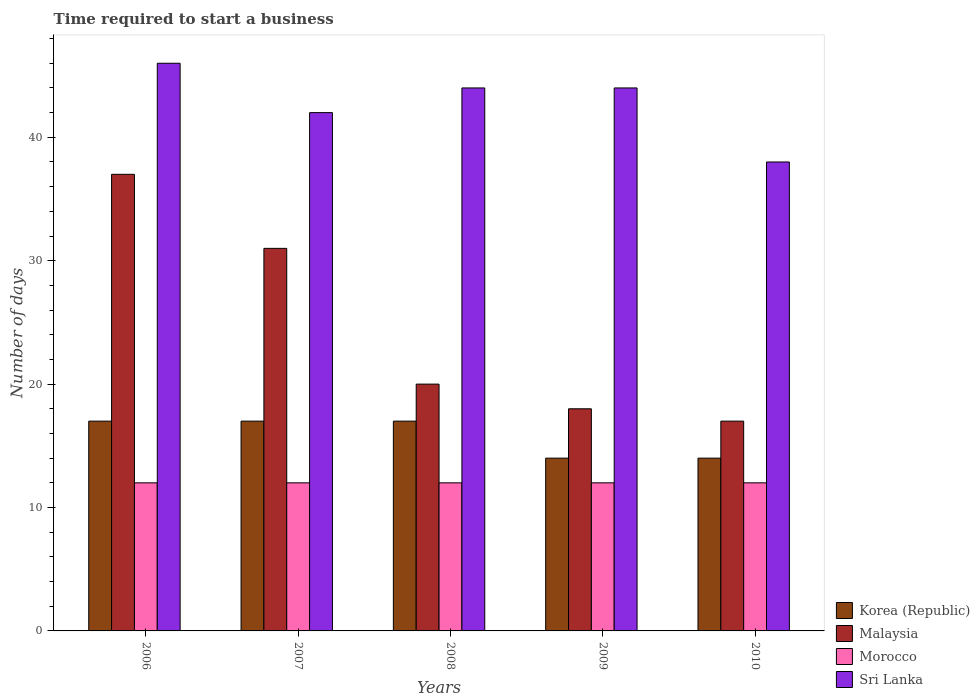How many groups of bars are there?
Provide a succinct answer. 5. Are the number of bars on each tick of the X-axis equal?
Your response must be concise. Yes. How many bars are there on the 3rd tick from the left?
Keep it short and to the point. 4. How many bars are there on the 1st tick from the right?
Keep it short and to the point. 4. What is the label of the 4th group of bars from the left?
Provide a short and direct response. 2009. In how many cases, is the number of bars for a given year not equal to the number of legend labels?
Your response must be concise. 0. What is the number of days required to start a business in Malaysia in 2007?
Offer a terse response. 31. Across all years, what is the maximum number of days required to start a business in Korea (Republic)?
Your answer should be compact. 17. Across all years, what is the minimum number of days required to start a business in Sri Lanka?
Make the answer very short. 38. What is the total number of days required to start a business in Malaysia in the graph?
Your answer should be very brief. 123. What is the difference between the number of days required to start a business in Korea (Republic) in 2006 and that in 2008?
Give a very brief answer. 0. What is the difference between the number of days required to start a business in Sri Lanka in 2010 and the number of days required to start a business in Morocco in 2006?
Offer a terse response. 26. In the year 2009, what is the difference between the number of days required to start a business in Malaysia and number of days required to start a business in Korea (Republic)?
Keep it short and to the point. 4. What is the difference between the highest and the second highest number of days required to start a business in Morocco?
Give a very brief answer. 0. What is the difference between the highest and the lowest number of days required to start a business in Korea (Republic)?
Make the answer very short. 3. In how many years, is the number of days required to start a business in Korea (Republic) greater than the average number of days required to start a business in Korea (Republic) taken over all years?
Ensure brevity in your answer.  3. What does the 2nd bar from the left in 2009 represents?
Make the answer very short. Malaysia. What does the 1st bar from the right in 2006 represents?
Provide a short and direct response. Sri Lanka. How many bars are there?
Ensure brevity in your answer.  20. What is the difference between two consecutive major ticks on the Y-axis?
Offer a terse response. 10. Does the graph contain any zero values?
Ensure brevity in your answer.  No. Does the graph contain grids?
Your answer should be compact. No. How are the legend labels stacked?
Offer a very short reply. Vertical. What is the title of the graph?
Your answer should be very brief. Time required to start a business. What is the label or title of the X-axis?
Your answer should be compact. Years. What is the label or title of the Y-axis?
Provide a succinct answer. Number of days. What is the Number of days in Korea (Republic) in 2006?
Offer a terse response. 17. What is the Number of days in Malaysia in 2006?
Offer a very short reply. 37. What is the Number of days of Morocco in 2006?
Ensure brevity in your answer.  12. What is the Number of days of Malaysia in 2007?
Offer a very short reply. 31. What is the Number of days of Malaysia in 2008?
Ensure brevity in your answer.  20. What is the Number of days in Sri Lanka in 2008?
Offer a terse response. 44. What is the Number of days of Malaysia in 2009?
Provide a succinct answer. 18. What is the Number of days of Morocco in 2009?
Give a very brief answer. 12. What is the Number of days of Sri Lanka in 2009?
Your answer should be very brief. 44. What is the Number of days in Malaysia in 2010?
Make the answer very short. 17. What is the Number of days in Morocco in 2010?
Offer a terse response. 12. Across all years, what is the maximum Number of days in Korea (Republic)?
Make the answer very short. 17. Across all years, what is the maximum Number of days in Morocco?
Provide a short and direct response. 12. Across all years, what is the minimum Number of days in Malaysia?
Provide a succinct answer. 17. Across all years, what is the minimum Number of days of Morocco?
Offer a terse response. 12. Across all years, what is the minimum Number of days in Sri Lanka?
Ensure brevity in your answer.  38. What is the total Number of days of Korea (Republic) in the graph?
Give a very brief answer. 79. What is the total Number of days in Malaysia in the graph?
Offer a very short reply. 123. What is the total Number of days of Morocco in the graph?
Offer a very short reply. 60. What is the total Number of days in Sri Lanka in the graph?
Your answer should be compact. 214. What is the difference between the Number of days of Malaysia in 2006 and that in 2007?
Provide a succinct answer. 6. What is the difference between the Number of days in Korea (Republic) in 2006 and that in 2009?
Ensure brevity in your answer.  3. What is the difference between the Number of days in Malaysia in 2006 and that in 2010?
Offer a terse response. 20. What is the difference between the Number of days of Morocco in 2006 and that in 2010?
Your answer should be very brief. 0. What is the difference between the Number of days of Sri Lanka in 2006 and that in 2010?
Your answer should be compact. 8. What is the difference between the Number of days in Malaysia in 2007 and that in 2008?
Your answer should be very brief. 11. What is the difference between the Number of days of Sri Lanka in 2007 and that in 2008?
Your answer should be very brief. -2. What is the difference between the Number of days in Morocco in 2007 and that in 2009?
Make the answer very short. 0. What is the difference between the Number of days in Sri Lanka in 2007 and that in 2009?
Your answer should be very brief. -2. What is the difference between the Number of days of Malaysia in 2007 and that in 2010?
Provide a short and direct response. 14. What is the difference between the Number of days of Morocco in 2007 and that in 2010?
Your answer should be very brief. 0. What is the difference between the Number of days in Morocco in 2008 and that in 2009?
Offer a terse response. 0. What is the difference between the Number of days of Sri Lanka in 2008 and that in 2009?
Provide a succinct answer. 0. What is the difference between the Number of days in Korea (Republic) in 2008 and that in 2010?
Make the answer very short. 3. What is the difference between the Number of days in Morocco in 2008 and that in 2010?
Your response must be concise. 0. What is the difference between the Number of days of Sri Lanka in 2008 and that in 2010?
Make the answer very short. 6. What is the difference between the Number of days in Malaysia in 2009 and that in 2010?
Your answer should be compact. 1. What is the difference between the Number of days in Morocco in 2009 and that in 2010?
Your answer should be very brief. 0. What is the difference between the Number of days of Sri Lanka in 2009 and that in 2010?
Your answer should be very brief. 6. What is the difference between the Number of days of Morocco in 2006 and the Number of days of Sri Lanka in 2007?
Provide a succinct answer. -30. What is the difference between the Number of days of Malaysia in 2006 and the Number of days of Sri Lanka in 2008?
Give a very brief answer. -7. What is the difference between the Number of days of Morocco in 2006 and the Number of days of Sri Lanka in 2008?
Offer a terse response. -32. What is the difference between the Number of days of Korea (Republic) in 2006 and the Number of days of Morocco in 2009?
Provide a short and direct response. 5. What is the difference between the Number of days of Korea (Republic) in 2006 and the Number of days of Sri Lanka in 2009?
Offer a terse response. -27. What is the difference between the Number of days in Malaysia in 2006 and the Number of days in Morocco in 2009?
Keep it short and to the point. 25. What is the difference between the Number of days in Morocco in 2006 and the Number of days in Sri Lanka in 2009?
Provide a short and direct response. -32. What is the difference between the Number of days of Korea (Republic) in 2006 and the Number of days of Malaysia in 2010?
Offer a very short reply. 0. What is the difference between the Number of days of Korea (Republic) in 2006 and the Number of days of Sri Lanka in 2010?
Your response must be concise. -21. What is the difference between the Number of days in Malaysia in 2006 and the Number of days in Morocco in 2010?
Provide a succinct answer. 25. What is the difference between the Number of days in Korea (Republic) in 2007 and the Number of days in Sri Lanka in 2008?
Provide a succinct answer. -27. What is the difference between the Number of days of Morocco in 2007 and the Number of days of Sri Lanka in 2008?
Your answer should be very brief. -32. What is the difference between the Number of days in Korea (Republic) in 2007 and the Number of days in Sri Lanka in 2009?
Offer a terse response. -27. What is the difference between the Number of days in Morocco in 2007 and the Number of days in Sri Lanka in 2009?
Offer a terse response. -32. What is the difference between the Number of days of Korea (Republic) in 2007 and the Number of days of Malaysia in 2010?
Ensure brevity in your answer.  0. What is the difference between the Number of days in Korea (Republic) in 2007 and the Number of days in Morocco in 2010?
Your answer should be very brief. 5. What is the difference between the Number of days in Malaysia in 2007 and the Number of days in Morocco in 2010?
Provide a succinct answer. 19. What is the difference between the Number of days in Malaysia in 2007 and the Number of days in Sri Lanka in 2010?
Give a very brief answer. -7. What is the difference between the Number of days in Korea (Republic) in 2008 and the Number of days in Malaysia in 2009?
Your response must be concise. -1. What is the difference between the Number of days in Malaysia in 2008 and the Number of days in Morocco in 2009?
Offer a terse response. 8. What is the difference between the Number of days of Morocco in 2008 and the Number of days of Sri Lanka in 2009?
Offer a terse response. -32. What is the difference between the Number of days in Korea (Republic) in 2008 and the Number of days in Sri Lanka in 2010?
Your answer should be compact. -21. What is the difference between the Number of days of Malaysia in 2008 and the Number of days of Morocco in 2010?
Provide a succinct answer. 8. What is the difference between the Number of days of Malaysia in 2008 and the Number of days of Sri Lanka in 2010?
Your answer should be compact. -18. What is the difference between the Number of days of Morocco in 2008 and the Number of days of Sri Lanka in 2010?
Provide a succinct answer. -26. What is the difference between the Number of days in Korea (Republic) in 2009 and the Number of days in Sri Lanka in 2010?
Your answer should be very brief. -24. What is the difference between the Number of days in Malaysia in 2009 and the Number of days in Sri Lanka in 2010?
Make the answer very short. -20. What is the difference between the Number of days in Morocco in 2009 and the Number of days in Sri Lanka in 2010?
Ensure brevity in your answer.  -26. What is the average Number of days of Malaysia per year?
Keep it short and to the point. 24.6. What is the average Number of days of Morocco per year?
Give a very brief answer. 12. What is the average Number of days in Sri Lanka per year?
Keep it short and to the point. 42.8. In the year 2006, what is the difference between the Number of days of Korea (Republic) and Number of days of Morocco?
Your answer should be compact. 5. In the year 2006, what is the difference between the Number of days in Korea (Republic) and Number of days in Sri Lanka?
Offer a terse response. -29. In the year 2006, what is the difference between the Number of days in Malaysia and Number of days in Morocco?
Provide a succinct answer. 25. In the year 2006, what is the difference between the Number of days of Malaysia and Number of days of Sri Lanka?
Your answer should be compact. -9. In the year 2006, what is the difference between the Number of days of Morocco and Number of days of Sri Lanka?
Make the answer very short. -34. In the year 2007, what is the difference between the Number of days of Korea (Republic) and Number of days of Morocco?
Give a very brief answer. 5. In the year 2007, what is the difference between the Number of days in Korea (Republic) and Number of days in Sri Lanka?
Provide a short and direct response. -25. In the year 2007, what is the difference between the Number of days in Malaysia and Number of days in Morocco?
Your response must be concise. 19. In the year 2008, what is the difference between the Number of days in Korea (Republic) and Number of days in Malaysia?
Your answer should be compact. -3. In the year 2008, what is the difference between the Number of days of Korea (Republic) and Number of days of Morocco?
Keep it short and to the point. 5. In the year 2008, what is the difference between the Number of days of Malaysia and Number of days of Morocco?
Your answer should be compact. 8. In the year 2008, what is the difference between the Number of days in Malaysia and Number of days in Sri Lanka?
Your answer should be very brief. -24. In the year 2008, what is the difference between the Number of days in Morocco and Number of days in Sri Lanka?
Offer a very short reply. -32. In the year 2009, what is the difference between the Number of days of Korea (Republic) and Number of days of Sri Lanka?
Provide a short and direct response. -30. In the year 2009, what is the difference between the Number of days in Morocco and Number of days in Sri Lanka?
Your response must be concise. -32. In the year 2010, what is the difference between the Number of days in Korea (Republic) and Number of days in Morocco?
Provide a short and direct response. 2. In the year 2010, what is the difference between the Number of days in Malaysia and Number of days in Morocco?
Offer a terse response. 5. In the year 2010, what is the difference between the Number of days of Malaysia and Number of days of Sri Lanka?
Your answer should be compact. -21. What is the ratio of the Number of days in Malaysia in 2006 to that in 2007?
Ensure brevity in your answer.  1.19. What is the ratio of the Number of days of Morocco in 2006 to that in 2007?
Offer a terse response. 1. What is the ratio of the Number of days in Sri Lanka in 2006 to that in 2007?
Make the answer very short. 1.1. What is the ratio of the Number of days of Korea (Republic) in 2006 to that in 2008?
Provide a succinct answer. 1. What is the ratio of the Number of days in Malaysia in 2006 to that in 2008?
Offer a terse response. 1.85. What is the ratio of the Number of days in Morocco in 2006 to that in 2008?
Keep it short and to the point. 1. What is the ratio of the Number of days in Sri Lanka in 2006 to that in 2008?
Your answer should be very brief. 1.05. What is the ratio of the Number of days of Korea (Republic) in 2006 to that in 2009?
Your response must be concise. 1.21. What is the ratio of the Number of days in Malaysia in 2006 to that in 2009?
Your answer should be very brief. 2.06. What is the ratio of the Number of days in Morocco in 2006 to that in 2009?
Your answer should be compact. 1. What is the ratio of the Number of days of Sri Lanka in 2006 to that in 2009?
Your answer should be very brief. 1.05. What is the ratio of the Number of days in Korea (Republic) in 2006 to that in 2010?
Your response must be concise. 1.21. What is the ratio of the Number of days in Malaysia in 2006 to that in 2010?
Make the answer very short. 2.18. What is the ratio of the Number of days in Morocco in 2006 to that in 2010?
Your response must be concise. 1. What is the ratio of the Number of days of Sri Lanka in 2006 to that in 2010?
Provide a succinct answer. 1.21. What is the ratio of the Number of days of Korea (Republic) in 2007 to that in 2008?
Provide a succinct answer. 1. What is the ratio of the Number of days of Malaysia in 2007 to that in 2008?
Offer a very short reply. 1.55. What is the ratio of the Number of days of Sri Lanka in 2007 to that in 2008?
Offer a very short reply. 0.95. What is the ratio of the Number of days in Korea (Republic) in 2007 to that in 2009?
Provide a short and direct response. 1.21. What is the ratio of the Number of days in Malaysia in 2007 to that in 2009?
Offer a terse response. 1.72. What is the ratio of the Number of days in Morocco in 2007 to that in 2009?
Keep it short and to the point. 1. What is the ratio of the Number of days of Sri Lanka in 2007 to that in 2009?
Give a very brief answer. 0.95. What is the ratio of the Number of days of Korea (Republic) in 2007 to that in 2010?
Offer a terse response. 1.21. What is the ratio of the Number of days of Malaysia in 2007 to that in 2010?
Keep it short and to the point. 1.82. What is the ratio of the Number of days of Morocco in 2007 to that in 2010?
Make the answer very short. 1. What is the ratio of the Number of days in Sri Lanka in 2007 to that in 2010?
Offer a terse response. 1.11. What is the ratio of the Number of days in Korea (Republic) in 2008 to that in 2009?
Provide a succinct answer. 1.21. What is the ratio of the Number of days in Morocco in 2008 to that in 2009?
Provide a short and direct response. 1. What is the ratio of the Number of days in Korea (Republic) in 2008 to that in 2010?
Offer a very short reply. 1.21. What is the ratio of the Number of days in Malaysia in 2008 to that in 2010?
Ensure brevity in your answer.  1.18. What is the ratio of the Number of days of Morocco in 2008 to that in 2010?
Your answer should be very brief. 1. What is the ratio of the Number of days of Sri Lanka in 2008 to that in 2010?
Provide a succinct answer. 1.16. What is the ratio of the Number of days in Korea (Republic) in 2009 to that in 2010?
Provide a short and direct response. 1. What is the ratio of the Number of days in Malaysia in 2009 to that in 2010?
Your answer should be very brief. 1.06. What is the ratio of the Number of days of Sri Lanka in 2009 to that in 2010?
Your answer should be compact. 1.16. What is the difference between the highest and the second highest Number of days of Korea (Republic)?
Offer a very short reply. 0. What is the difference between the highest and the lowest Number of days in Korea (Republic)?
Provide a succinct answer. 3. What is the difference between the highest and the lowest Number of days of Malaysia?
Keep it short and to the point. 20. What is the difference between the highest and the lowest Number of days in Sri Lanka?
Your response must be concise. 8. 